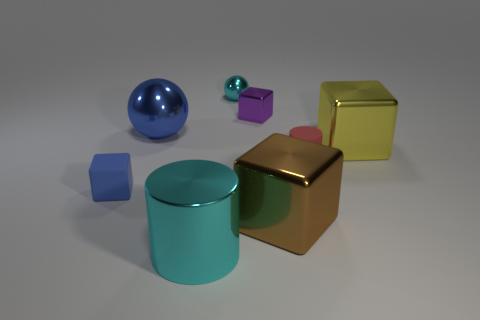Subtract 1 cubes. How many cubes are left? 3 Subtract all green cubes. Subtract all blue spheres. How many cubes are left? 4 Add 2 large yellow metal cylinders. How many objects exist? 10 Subtract all spheres. How many objects are left? 6 Subtract all brown metal things. Subtract all small metal cubes. How many objects are left? 6 Add 2 small cyan things. How many small cyan things are left? 3 Add 7 large gray shiny blocks. How many large gray shiny blocks exist? 7 Subtract 1 cyan spheres. How many objects are left? 7 